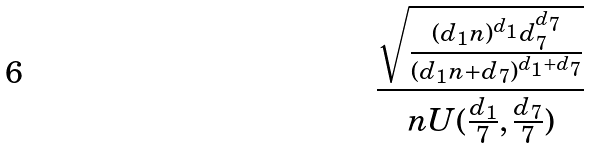Convert formula to latex. <formula><loc_0><loc_0><loc_500><loc_500>\frac { \sqrt { \frac { ( d _ { 1 } n ) ^ { d _ { 1 } } d _ { 7 } ^ { d _ { 7 } } } { ( d _ { 1 } n + d _ { 7 } ) ^ { d _ { 1 } + d _ { 7 } } } } } { n U ( \frac { d _ { 1 } } { 7 } , \frac { d _ { 7 } } { 7 } ) }</formula> 